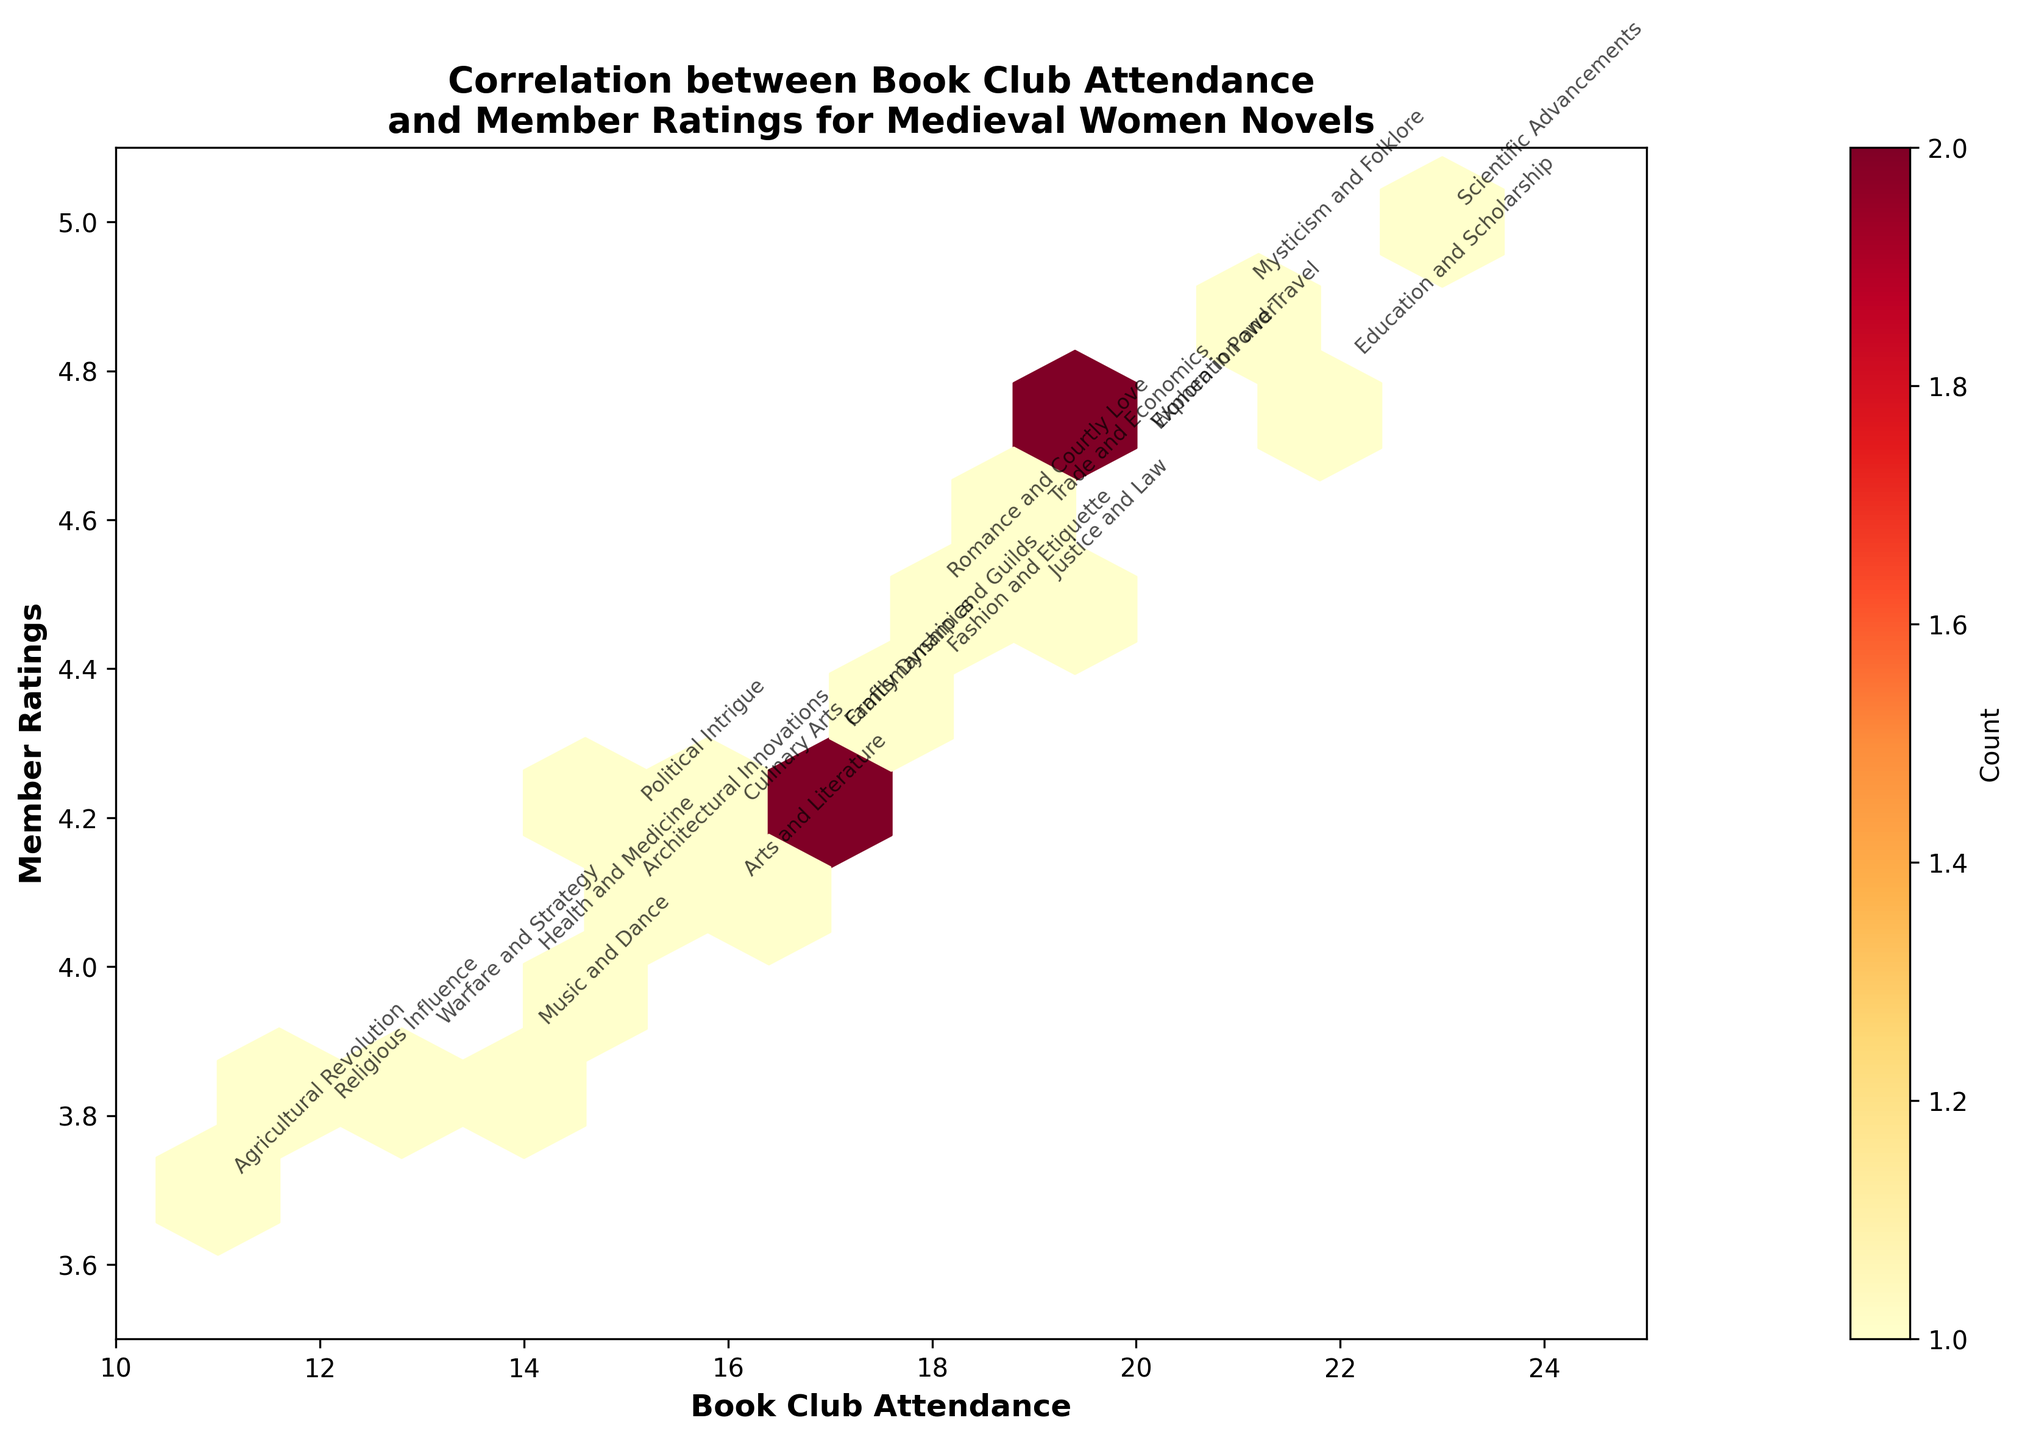What's the title of the hexbin plot? The title is prominently displayed at the top of the figure. It reads, "Correlation between Book Club Attendance and Member Ratings for Medieval Women Novels."
Answer: Correlation between Book Club Attendance and Member Ratings for Medieval Women Novels What are the labels of the x-axis and y-axis? The x-axis and y-axis labels are clearly indicated just below and to the left of the plot, respectively. The x-axis is labeled "Book Club Attendance" and the y-axis is labeled "Member Ratings."
Answer: Book Club Attendance and Member Ratings Which theme had the highest attendance, and what was the rating associated with it? According to the annotations in the plot, the theme "Scientific Advancements" had the highest attendance of 23 people with a corresponding rating of 5.0.
Answer: Scientific Advancements, 5.0 How many themes had a member rating of 4.5 or higher? From the plot, count the number of hexagons filled for ratings 4.5, 4.6, 4.7, 4.8, 4.9, and 5.0. There are 8 themes with ratings of 4.5 or higher: Political Intrigue, Women in Power, Trade and Economics, Education and Scholarship, Mysticism and Folklore, Exploration and Travel, Justice and Law, and Scientific Advancements.
Answer: 8 themes What is the average book club attendance for themes rated 4.7? There are two themes with a rating of 4.7: Women in Power and Exploration and Travel. Their respective attendances are 20 and 20. Adding these and dividing by 2 gives (20 + 20) / 2 = 20.
Answer: 20 Which theme associated with the lowest attendance had a rating above 4.0? The theme with the lowest attendance (11) is "Agricultural Revolution" with a rating of 3.7, which is below 4.0. The next lowest attendance is 12 for "Religious Influence" with a rating of 3.8. Therefore, the theme is "Religious Influence" with attendance of 12 and rating above 4.0. For themes above 4.0, "Architectural Innovations" had an attendance of 15 and a rating of 4.1.
Answer: Architectural Innovations Which theme is centered at the hexagon with the highest density? The color bar indicates the density of hexagons. The darkest (most dense) hexagon will be the highest density. Observe the plot to find the densest hexagon and check its annotation. The highest density hexagon is centered around the "Romance and Courtly Love" theme with attendance of 18 and rating of 4.5.
Answer: Romance and Courtly Love Are there more themes with attendance above or below 17? Count the number of individual data points for themes with attendance above 17 and below 17. Attendance above 17 (18, 19, 20, 21, 22, 23 with respective counts): 18, 18, 19, 19, 20, 20, 21, 22, 23 = 9 themes. Attendance below 17 (15, 16, 14, 13, 12, 11 with respective counts): 15, 16, 14, 13, 12, 11 = 6 themes. Hence, there are more themes with attendance above 17.
Answer: Above 17 Do themes with higher ratings generally have higher attendance? To determine this, compare the distribution of attendance across the rating spectrum. Observationally, themes with higher ratings (above 4.5) tend to have higher attendance counts, indicating a general positive correlation.
Answer: Yes What's the predominant color for hexagons and what does it indicate about most data points? The predominant color in the hexbin plot is an intermediate shade of the color map, which usually indicates moderate density. This suggests that most of the data points are distributed relatively evenly without extreme clustering.
Answer: Moderate density 